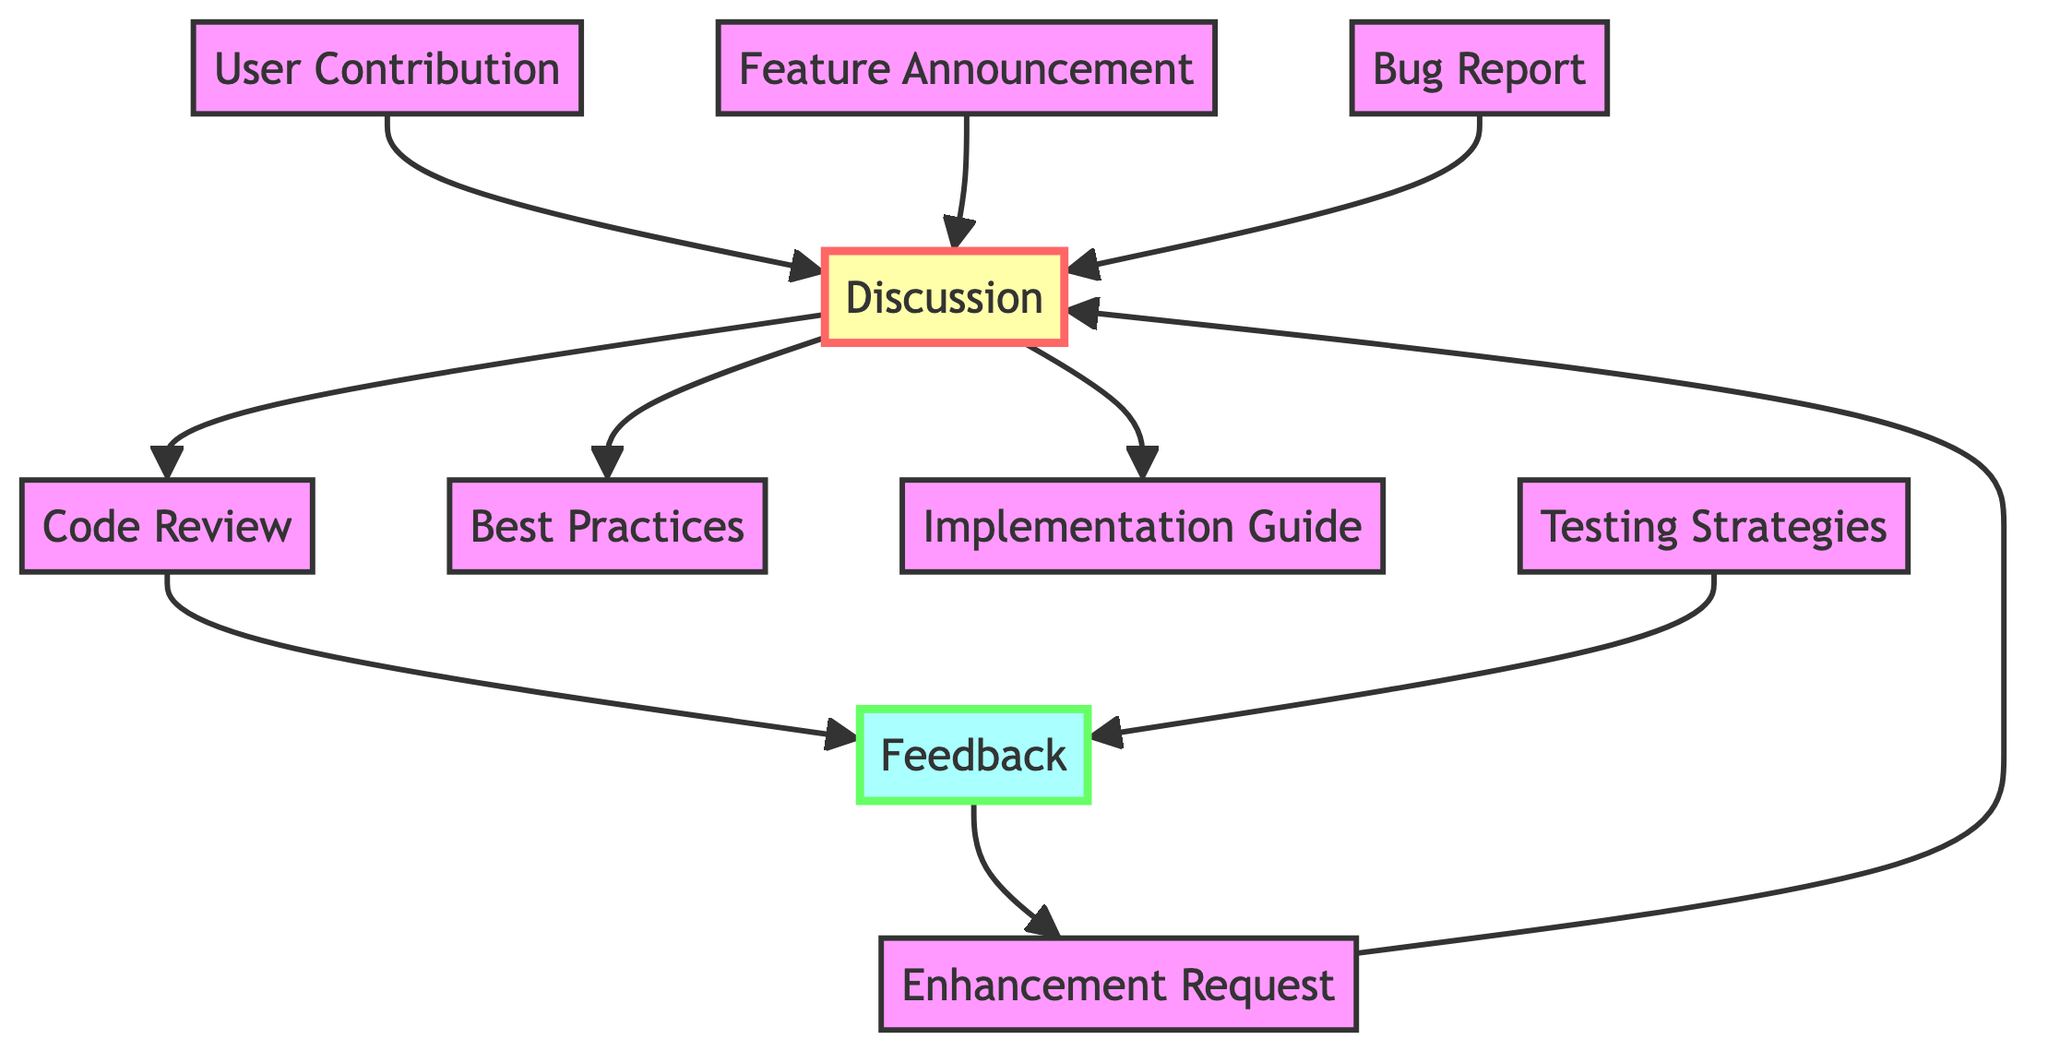What is the total number of nodes in the diagram? The diagram lists ten unique nodes: User Contribution, Feature Announcement, Enhancement Request, Bug Report, Code Review, Best Practices, Discussion, Implementation Guide, Testing Strategies, and Feedback. Counting these gives a total of ten nodes.
Answer: ten Which nodes contribute to the Discussion? The nodes connecting to the Discussion are User Contribution, Feature Announcement, Enhancement Request, and Bug Report. Each of these nodes has a directed line leading to the Discussion node. Summing these gives four contributing nodes.
Answer: four What is the relationship between Feedback and Enhancement Request? The diagram shows that Feedback has a directed edge pointing towards Enhancement Request. This indicates that Feedback influences or is related to Enhancement Request in the flow of the discussion.
Answer: Feedback influences Enhancement Request How many edges are there leading out of the Discussion node? From the Discussion node, there are three edges: one leading to Code Review, another to Best Practices, and a third to Implementation Guide. Counting these edges gives a total of three.
Answer: three Which node is the last in the flow after Testing Strategies? Following Testing Strategies in the diagram, there is an edge to Feedback. This implies that the output of Testing Strategies leads to Feedback, marking it as the last node in that flow.
Answer: Feedback Is Bug Report connected directly to Code Review? The diagram does not show a direct edge from Bug Report to Code Review. Instead, Bug Report connects to Discussion, which then connects to Code Review. Thus, Bug Report is not directly linked to Code Review.
Answer: No Which two nodes are likely to provide best practices based on the Discussion? The Discussion node leads to Best Practices, indicating that it is meant to provide insights on best practices. As there are multiple paths leading to Discussion, various nodes can contribute to this, but specifically, Best Practices is directly linked as the output.
Answer: Best Practices Which node would you reach last if starting from Feature Announcement? Starting from Feature Announcement, the path flows to Discussion. From Discussion, the only destinations are Code Review, Best Practices, and Implementation Guide. If we follow this through, there is no continuing path from those into another node. Therefore, based on direct output, the last reached node is Code Review, which then leads to Feedback. However, due to its termination, Best Practices and Implementation Guide can be viewed similarly as last outputs.
Answer: Code Review (or Best Practices, Implementation Guide) 